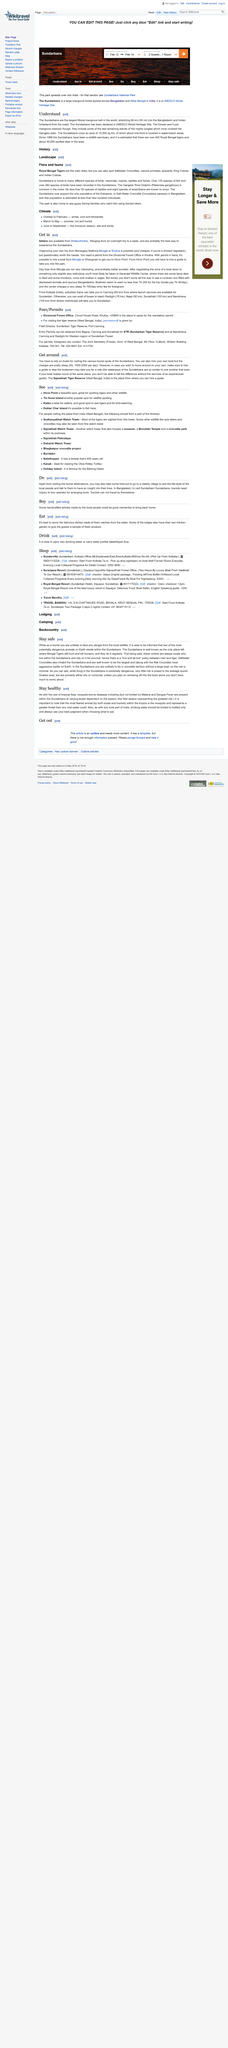Indicate a few pertinent items in this graphic. Yes, they do exist in the Sundarbans. The Sundarbans is located in Bangladesh. To stay healthy in rural parts of India, it is recommended that bottled drinking water should be limited and that one should exercise caution when consuming food. Yes, it is true that crocodiles inhabit the Sundarbans. The Sundarbans are located on the Bangladeshi and Indian hinterland, bordering the coast of the Bay of Bengal, and are known for being the largest mangrove forest in the world. 